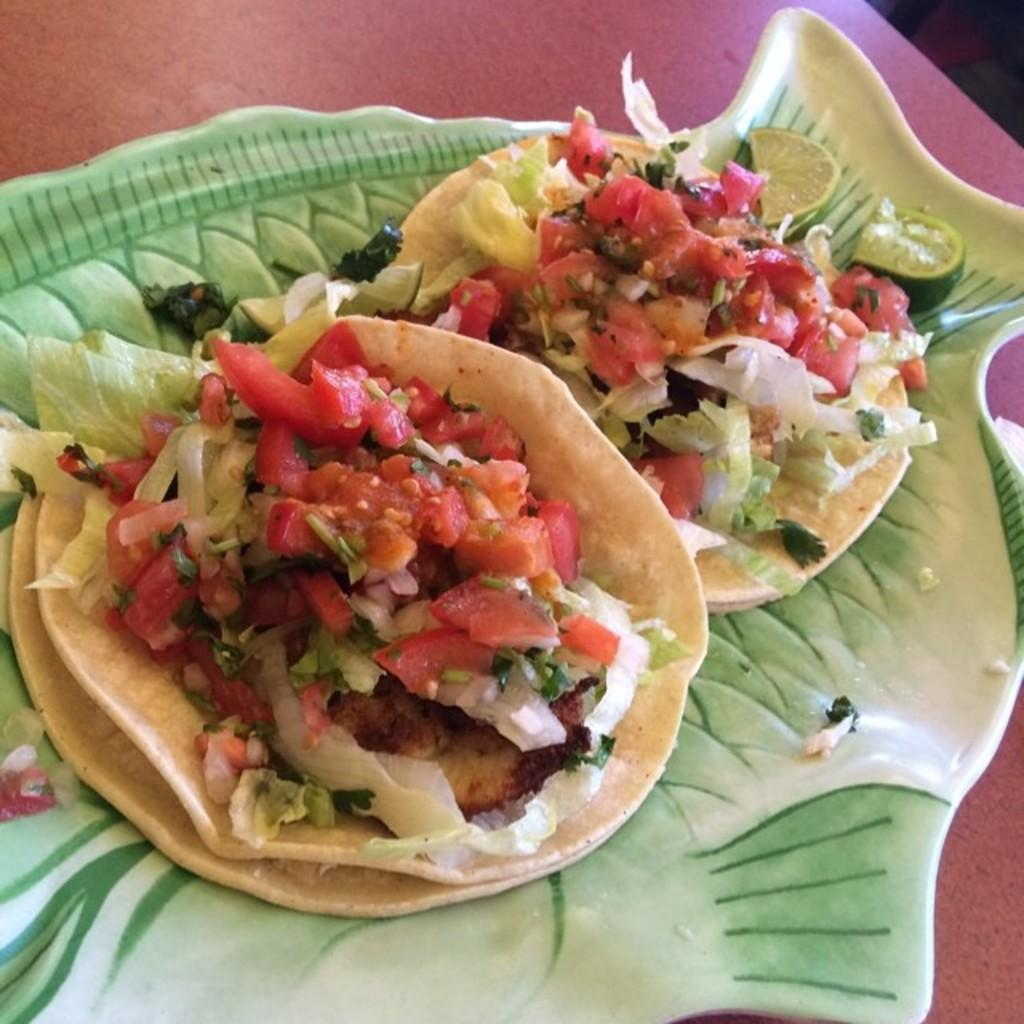What is on the plate that is visible in the image? There are food items on a plate in the image. What colors are present on the plate? The plate has green and white colors. What colors can be seen in the food on the plate? The food has red, orange, white, and cream colors. What is the color of the table the plate is on? The plate is on a red table. Can you hear a whistle in the image? There is no whistle present in the image; it is a still image of food on a plate. 